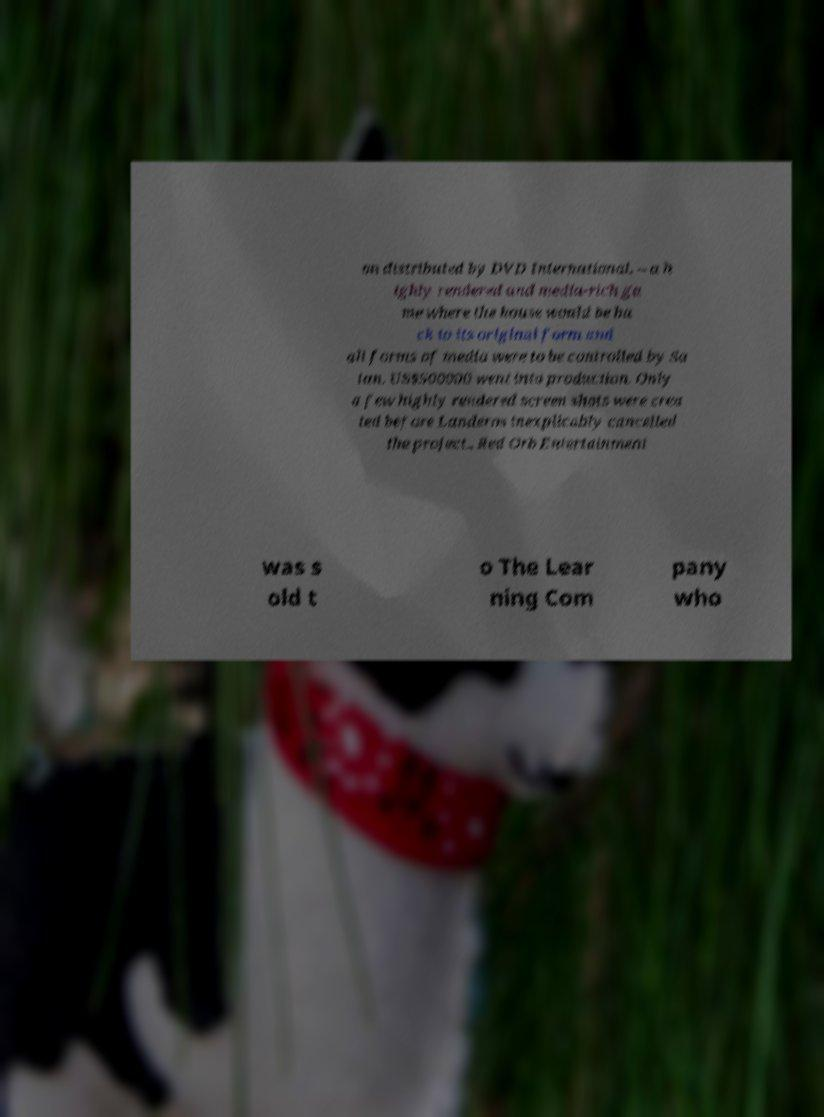Can you accurately transcribe the text from the provided image for me? on distributed by DVD International. – a h ighly rendered and media-rich ga me where the house would be ba ck to its original form and all forms of media were to be controlled by Sa tan. US$500000 went into production. Only a few highly rendered screen shots were crea ted before Landeros inexplicably cancelled the project.. Red Orb Entertainment was s old t o The Lear ning Com pany who 